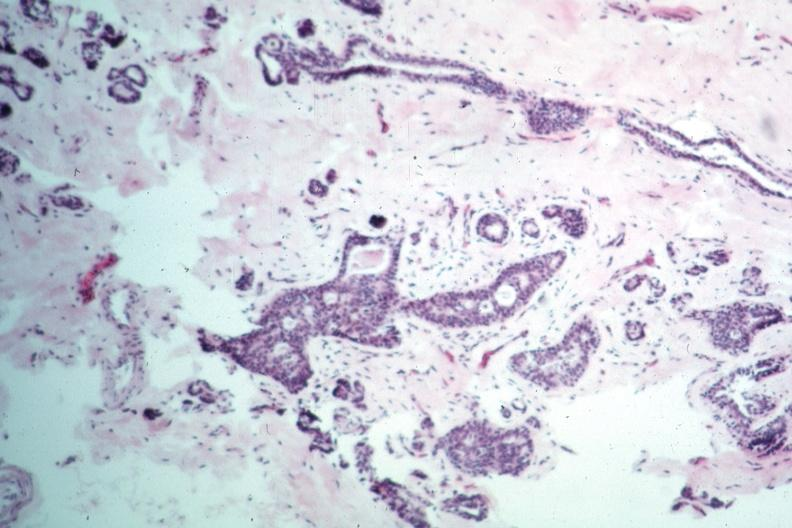s natural color present?
Answer the question using a single word or phrase. No 